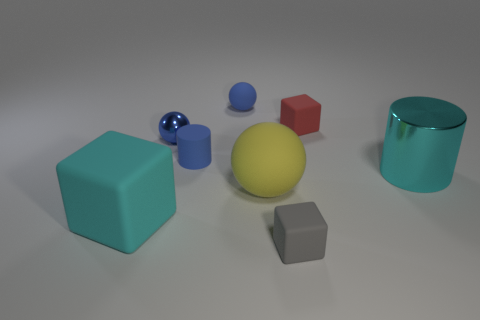Add 1 blue objects. How many objects exist? 9 Subtract all spheres. How many objects are left? 5 Subtract all large brown metallic blocks. Subtract all tiny red objects. How many objects are left? 7 Add 6 cylinders. How many cylinders are left? 8 Add 4 gray metal cylinders. How many gray metal cylinders exist? 4 Subtract 1 blue cylinders. How many objects are left? 7 